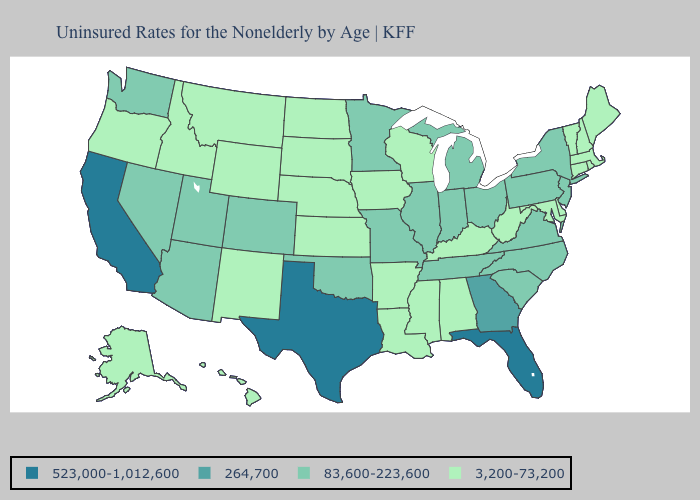Is the legend a continuous bar?
Keep it brief. No. Name the states that have a value in the range 83,600-223,600?
Concise answer only. Arizona, Colorado, Illinois, Indiana, Michigan, Minnesota, Missouri, Nevada, New Jersey, New York, North Carolina, Ohio, Oklahoma, Pennsylvania, South Carolina, Tennessee, Utah, Virginia, Washington. What is the value of West Virginia?
Quick response, please. 3,200-73,200. Among the states that border Maryland , does Delaware have the lowest value?
Be succinct. Yes. What is the value of Ohio?
Short answer required. 83,600-223,600. What is the value of Missouri?
Answer briefly. 83,600-223,600. What is the value of Arizona?
Concise answer only. 83,600-223,600. What is the lowest value in the USA?
Keep it brief. 3,200-73,200. What is the lowest value in the USA?
Short answer required. 3,200-73,200. Which states have the lowest value in the USA?
Give a very brief answer. Alabama, Alaska, Arkansas, Connecticut, Delaware, Hawaii, Idaho, Iowa, Kansas, Kentucky, Louisiana, Maine, Maryland, Massachusetts, Mississippi, Montana, Nebraska, New Hampshire, New Mexico, North Dakota, Oregon, Rhode Island, South Dakota, Vermont, West Virginia, Wisconsin, Wyoming. What is the value of Alaska?
Quick response, please. 3,200-73,200. Among the states that border Ohio , does Michigan have the highest value?
Short answer required. Yes. What is the highest value in states that border Missouri?
Write a very short answer. 83,600-223,600. Among the states that border Illinois , does Indiana have the highest value?
Answer briefly. Yes. What is the value of Hawaii?
Answer briefly. 3,200-73,200. 